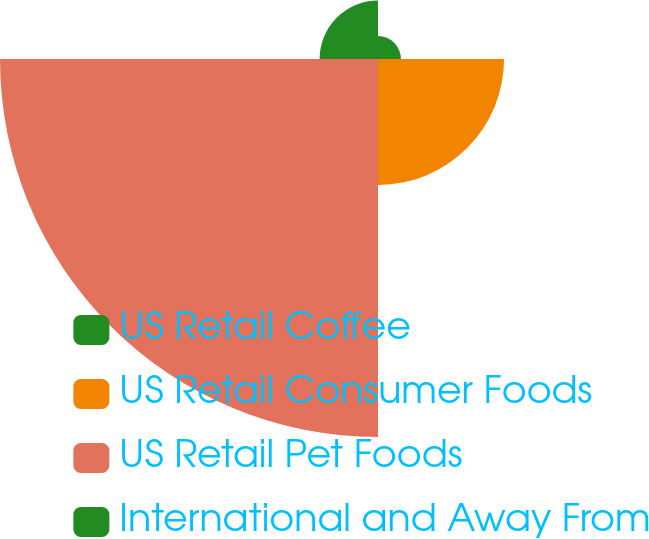<chart> <loc_0><loc_0><loc_500><loc_500><pie_chart><fcel>US Retail Coffee<fcel>US Retail Consumer Foods<fcel>US Retail Pet Foods<fcel>International and Away From<nl><fcel>3.91%<fcel>21.53%<fcel>64.58%<fcel>9.98%<nl></chart> 